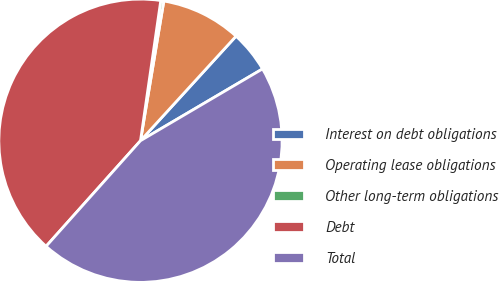Convert chart to OTSL. <chart><loc_0><loc_0><loc_500><loc_500><pie_chart><fcel>Interest on debt obligations<fcel>Operating lease obligations<fcel>Other long-term obligations<fcel>Debt<fcel>Total<nl><fcel>4.75%<fcel>9.15%<fcel>0.35%<fcel>40.68%<fcel>45.08%<nl></chart> 